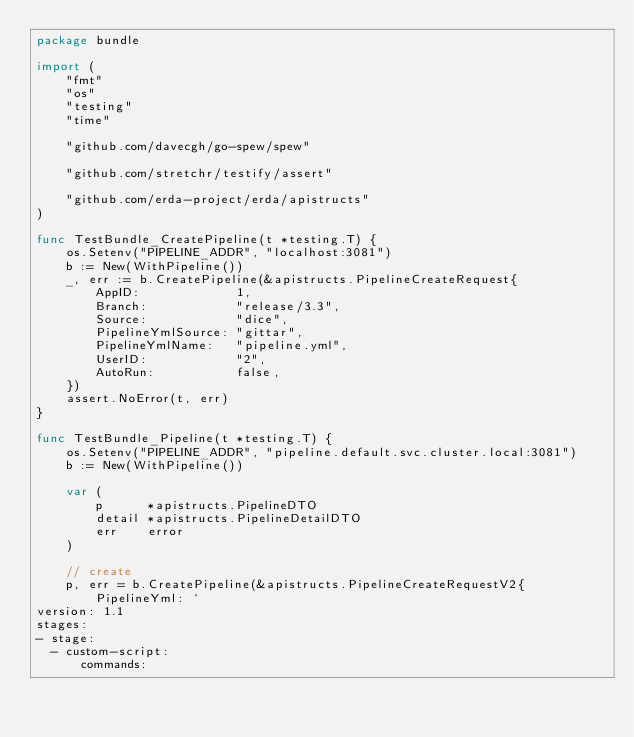Convert code to text. <code><loc_0><loc_0><loc_500><loc_500><_Go_>package bundle

import (
	"fmt"
	"os"
	"testing"
	"time"

	"github.com/davecgh/go-spew/spew"

	"github.com/stretchr/testify/assert"

	"github.com/erda-project/erda/apistructs"
)

func TestBundle_CreatePipeline(t *testing.T) {
	os.Setenv("PIPELINE_ADDR", "localhost:3081")
	b := New(WithPipeline())
	_, err := b.CreatePipeline(&apistructs.PipelineCreateRequest{
		AppID:             1,
		Branch:            "release/3.3",
		Source:            "dice",
		PipelineYmlSource: "gittar",
		PipelineYmlName:   "pipeline.yml",
		UserID:            "2",
		AutoRun:           false,
	})
	assert.NoError(t, err)
}

func TestBundle_Pipeline(t *testing.T) {
	os.Setenv("PIPELINE_ADDR", "pipeline.default.svc.cluster.local:3081")
	b := New(WithPipeline())

	var (
		p      *apistructs.PipelineDTO
		detail *apistructs.PipelineDetailDTO
		err    error
	)

	// create
	p, err = b.CreatePipeline(&apistructs.PipelineCreateRequestV2{
		PipelineYml: `
version: 1.1
stages:
- stage:
  - custom-script:
      commands:</code> 